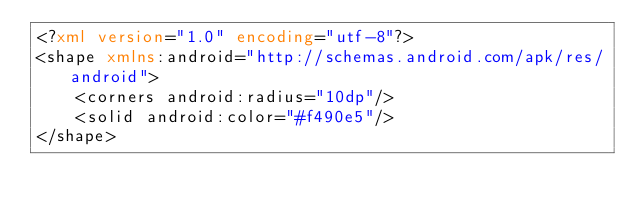Convert code to text. <code><loc_0><loc_0><loc_500><loc_500><_XML_><?xml version="1.0" encoding="utf-8"?>
<shape xmlns:android="http://schemas.android.com/apk/res/android">
    <corners android:radius="10dp"/>
    <solid android:color="#f490e5"/>
</shape></code> 